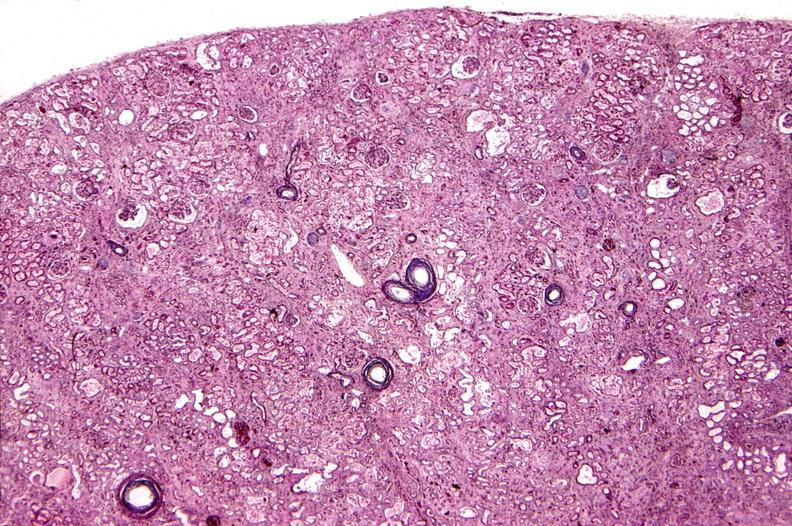does this image show kidney, arteriolonephrosclerosis, malignant hypertension?
Answer the question using a single word or phrase. Yes 